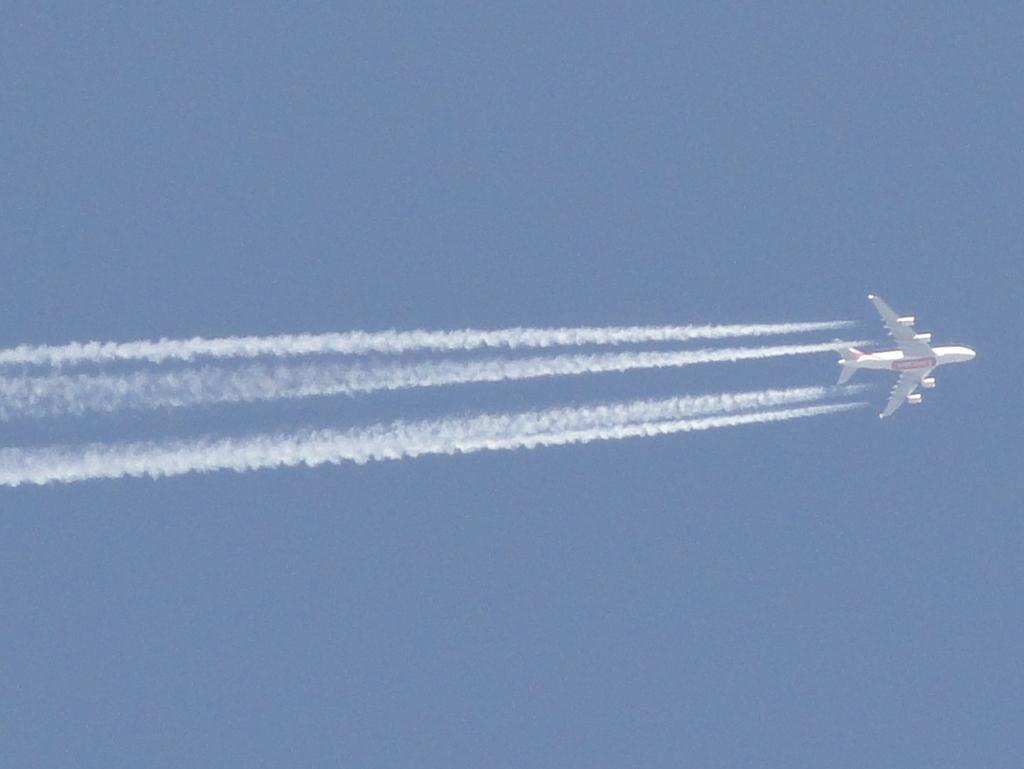Can you describe this image briefly? In the image we can see there is an aeroplane flying in the sky and there is smoke in the air. The sky is clear. 